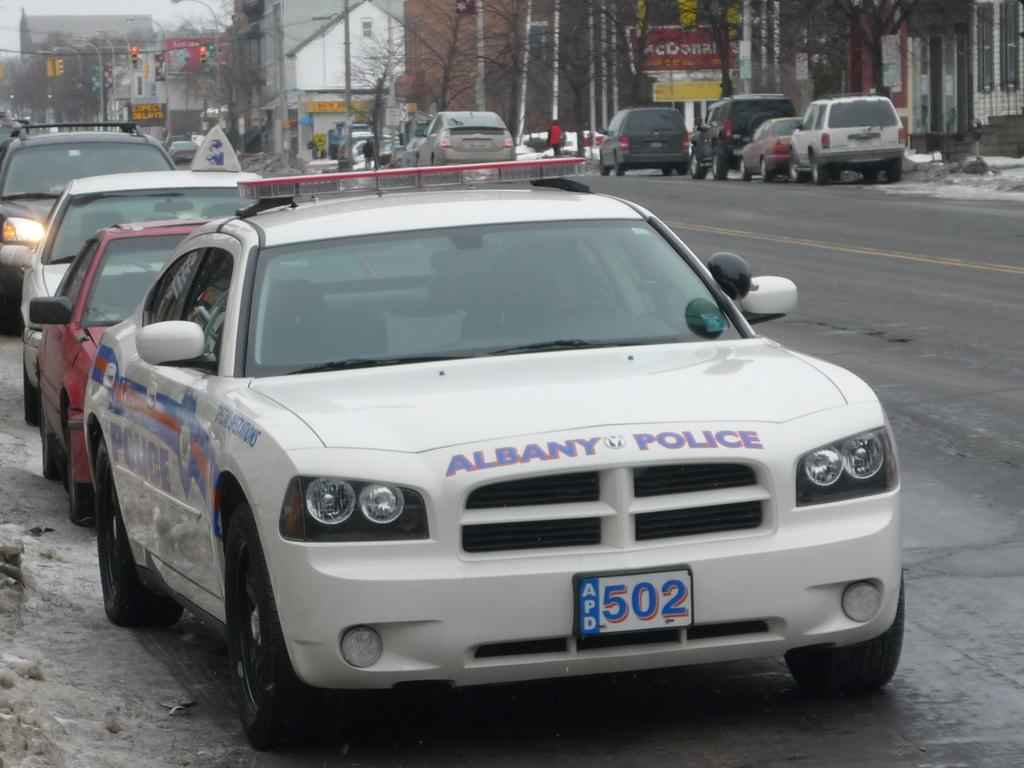What type of vehicle is in the image? There is a police vehicle in the image. What color is the police vehicle? The police vehicle is white in color. Where is the police vehicle located? The police vehicle is on the road. What can be seen at the top of the image? There are signals visible at the top of the image. What type of vegetation is on the right side of the image? There are trees on the right side of the image. How many visitors are sitting on the cows in the image? There are no visitors or cows present in the image; it features a police vehicle on the road. 